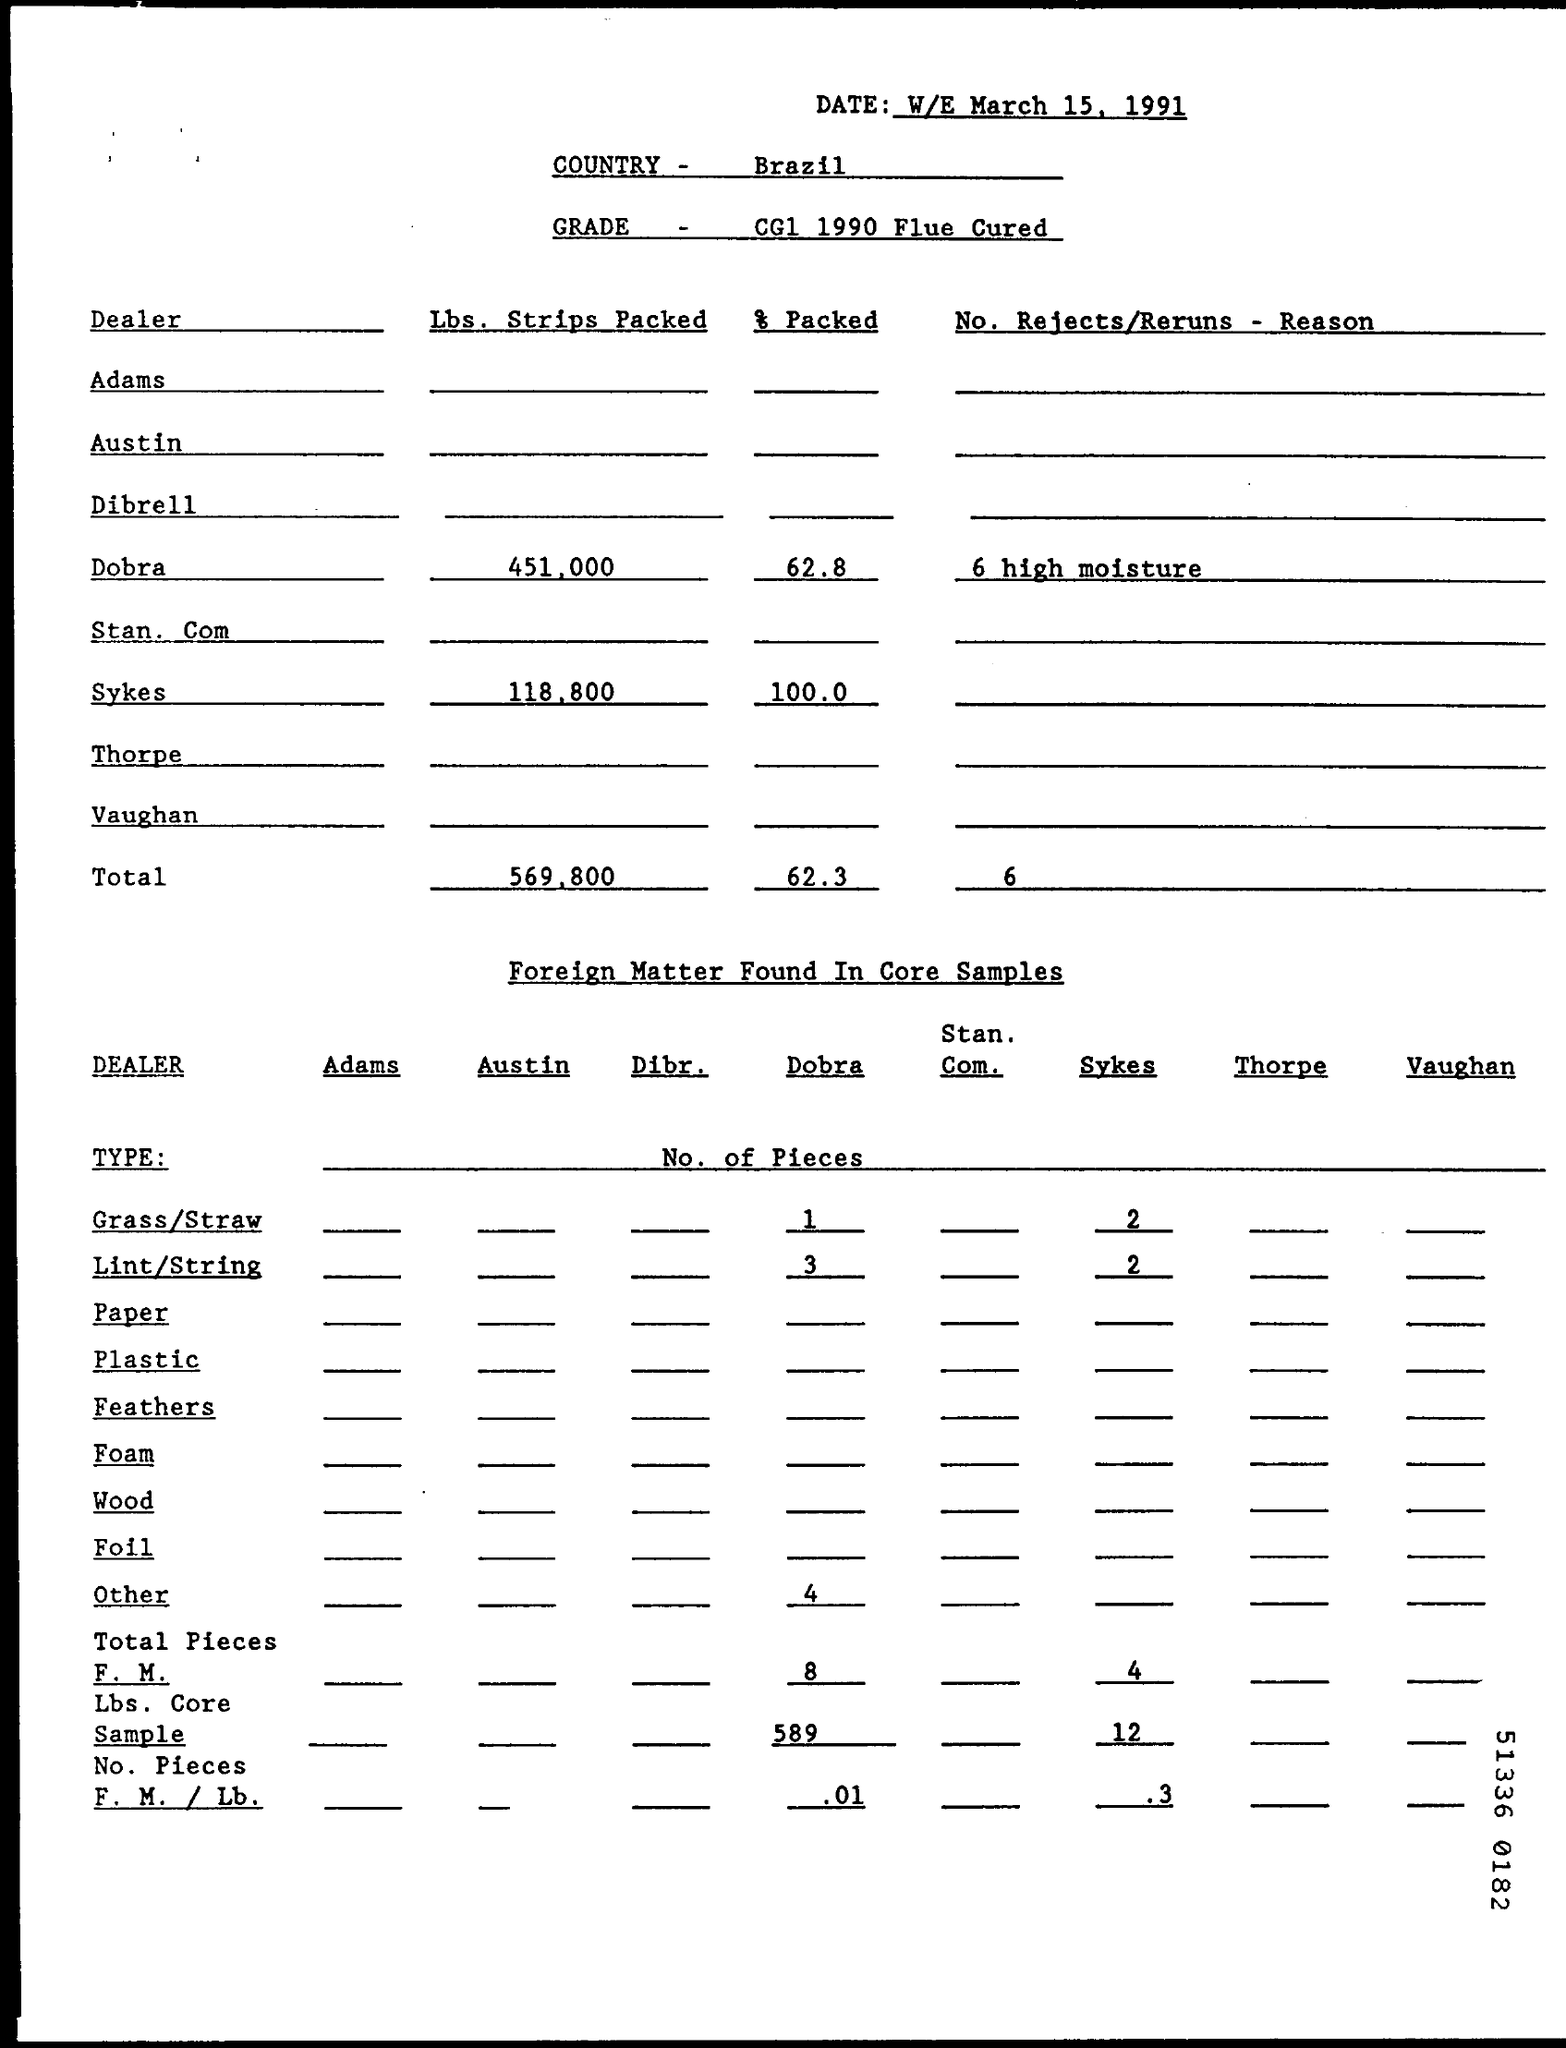What is the Total Lbs. Strips Packed?
 569,800 